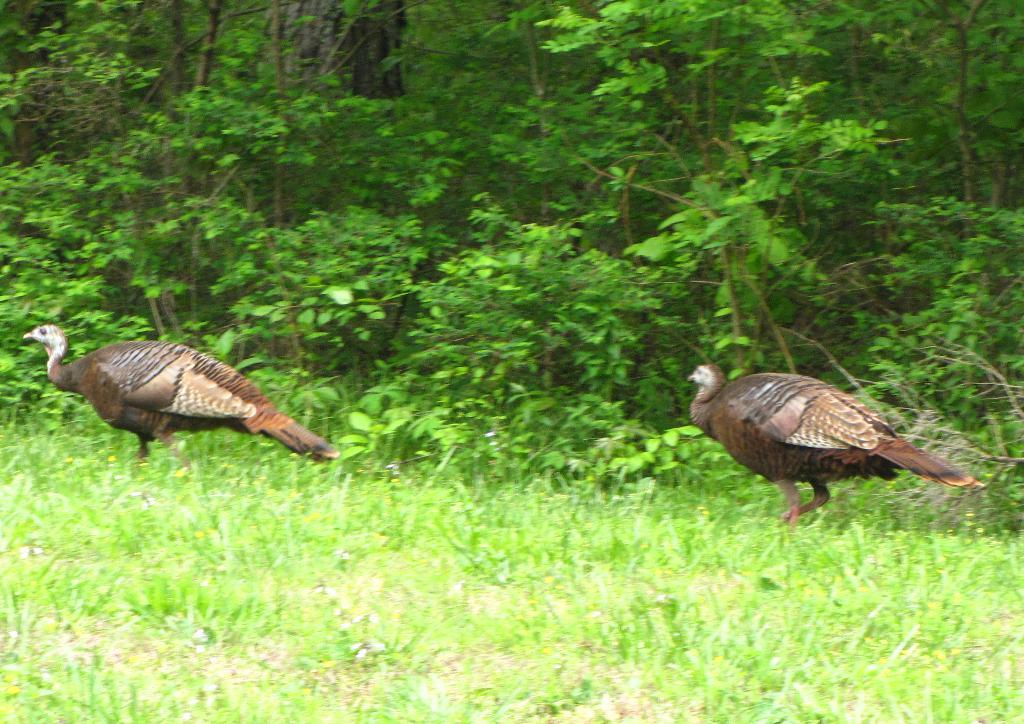What is located in the center of the image? There are birds in the center of the image. What type of vegetation is at the bottom of the image? There is grass at the bottom of the image. What can be seen in the background of the image? There are trees in the background of the image. What type of music can be heard coming from the crib in the image? There is no crib present in the image, and therefore no music can be heard coming from it. 